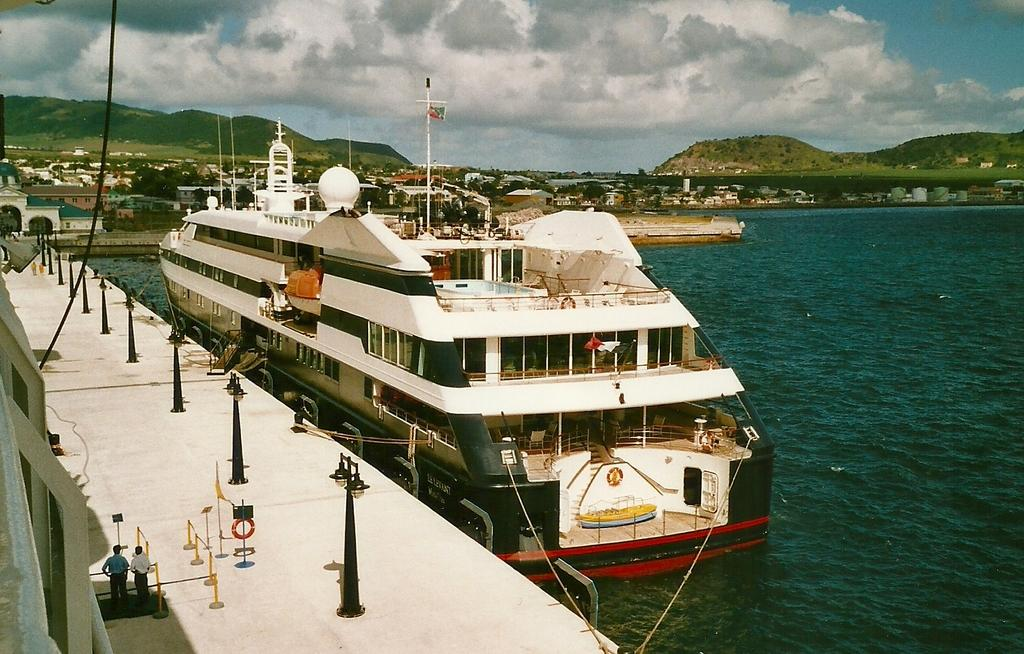What type of natural elements can be seen in the image? There are trees and mountains visible in the image. What type of man-made structures are present in the image? There are buildings and light poles in the image. What mode of transportation is present in the image? There is a boat in the image. Are there any people in the image? Yes, there are people in the image. What is the color of the sky in the image? The sky is in white and blue color. Can you see the father of the people in the image? There is no information about the people's parents in the image, so we cannot determine if their father is present. Are there any fairies flying around the trees in the image? There is no mention of fairies in the image, so we cannot confirm their presence. 